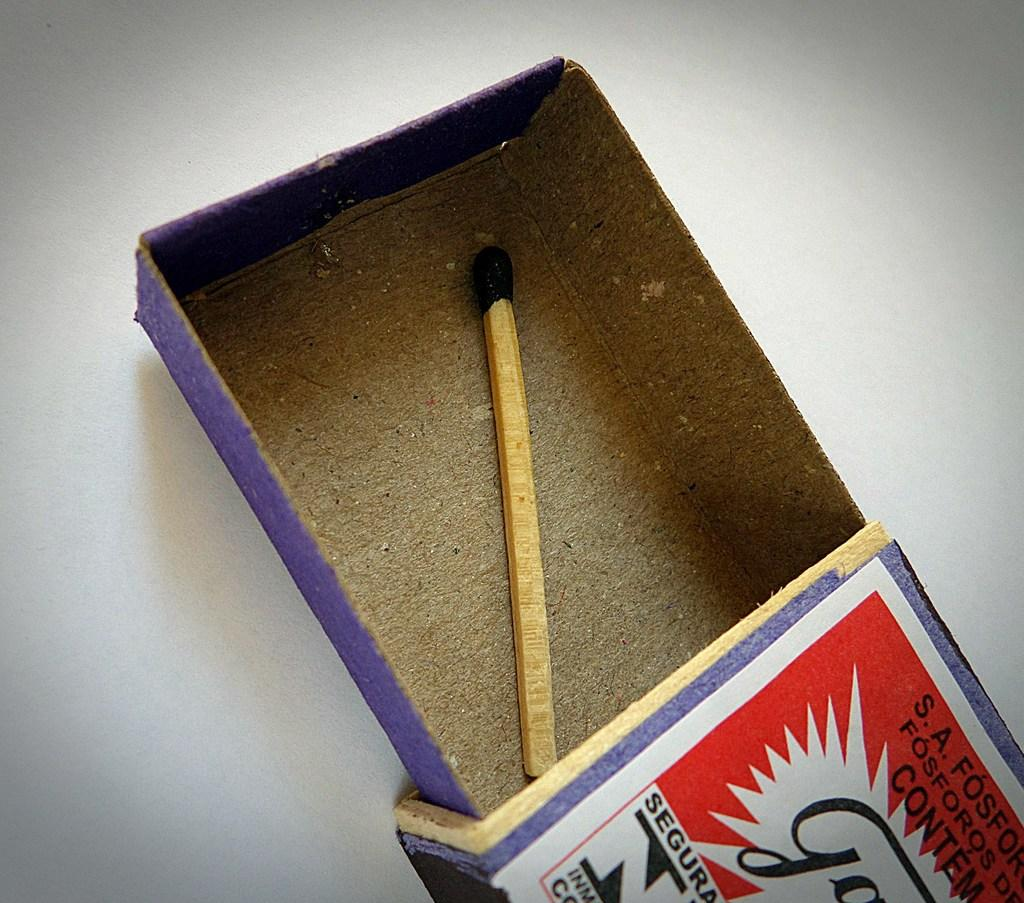<image>
Present a compact description of the photo's key features. one match is in the S.A fosfonr box and it looks to be used 